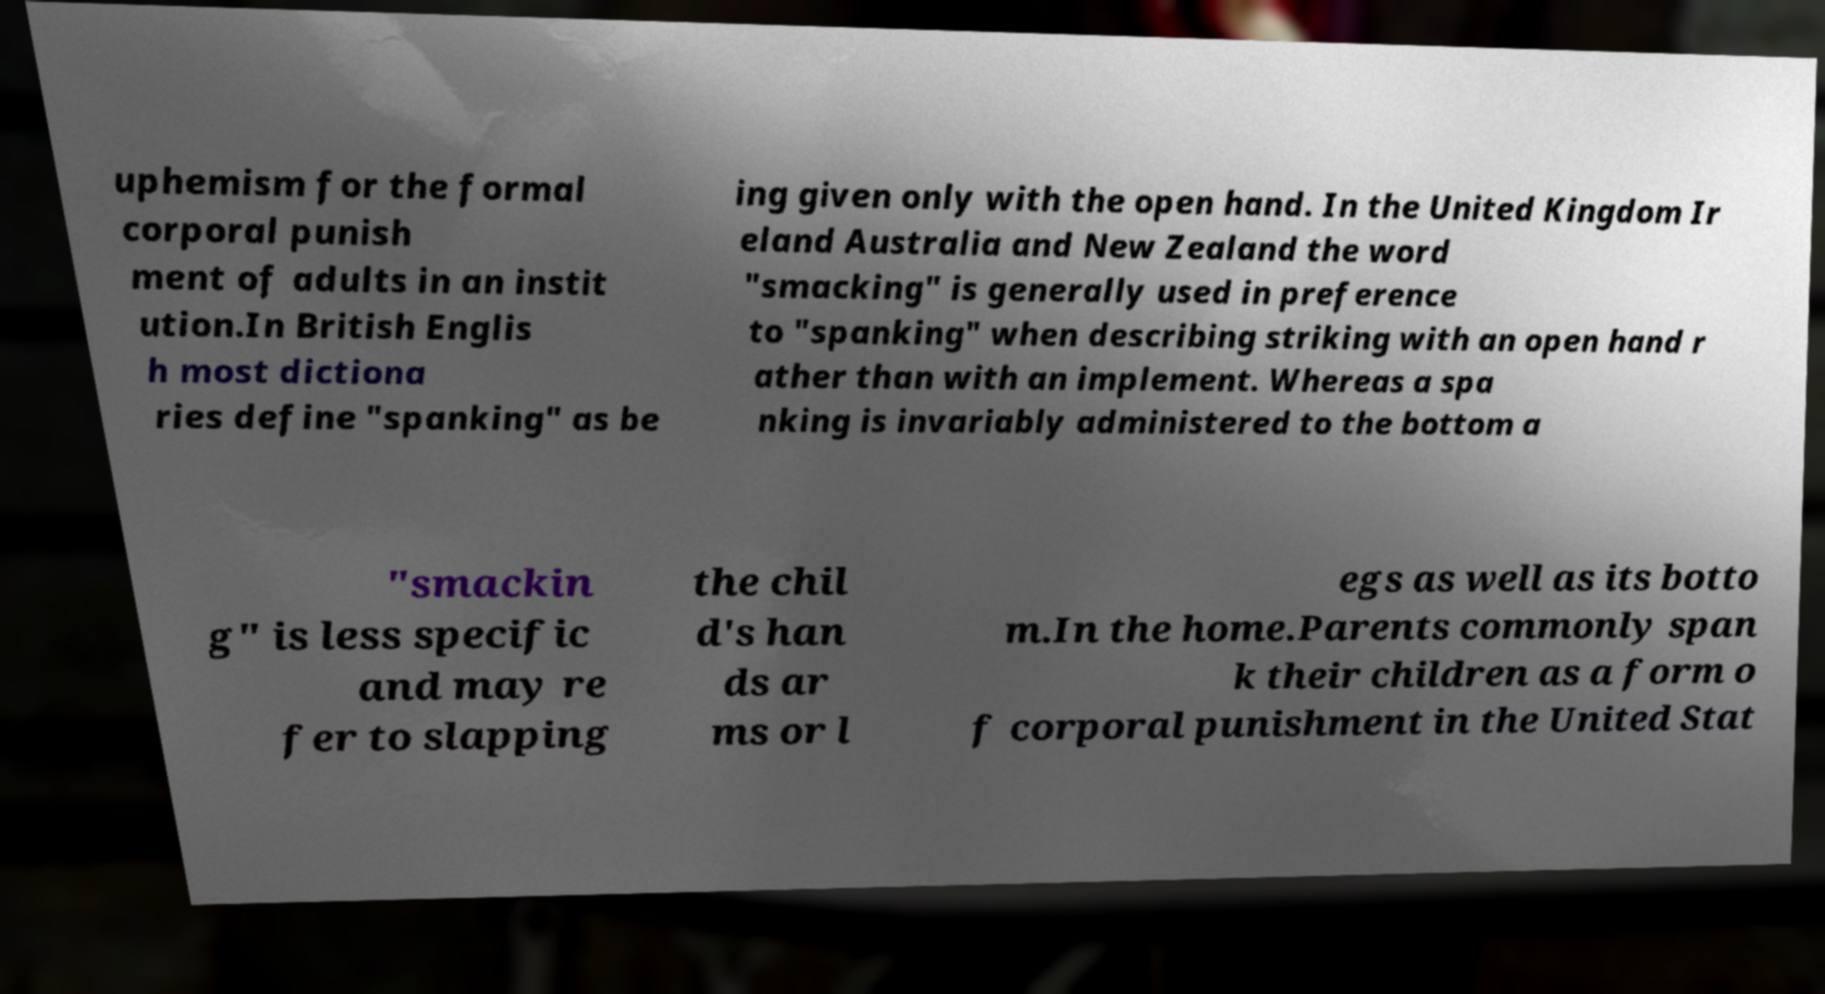For documentation purposes, I need the text within this image transcribed. Could you provide that? uphemism for the formal corporal punish ment of adults in an instit ution.In British Englis h most dictiona ries define "spanking" as be ing given only with the open hand. In the United Kingdom Ir eland Australia and New Zealand the word "smacking" is generally used in preference to "spanking" when describing striking with an open hand r ather than with an implement. Whereas a spa nking is invariably administered to the bottom a "smackin g" is less specific and may re fer to slapping the chil d's han ds ar ms or l egs as well as its botto m.In the home.Parents commonly span k their children as a form o f corporal punishment in the United Stat 